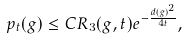Convert formula to latex. <formula><loc_0><loc_0><loc_500><loc_500>p _ { t } ( g ) \leq C R _ { 3 } ( g , t ) e ^ { - \frac { d ( g ) ^ { 2 } } { 4 t } } ,</formula> 